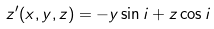<formula> <loc_0><loc_0><loc_500><loc_500>z ^ { \prime } ( x , y , z ) = - y \sin i + z \cos i</formula> 